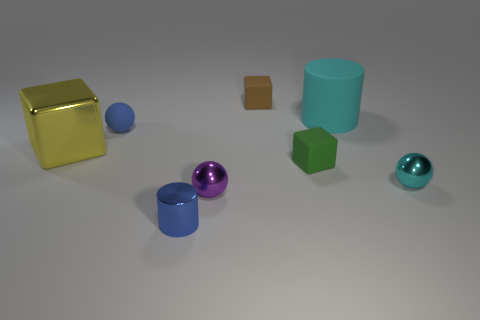How big is the block on the left side of the small ball that is to the left of the small metal cylinder?
Make the answer very short. Large. What shape is the shiny thing that is the same color as the big cylinder?
Offer a terse response. Sphere. What number of balls are gray rubber objects or cyan metallic objects?
Offer a terse response. 1. There is a green rubber cube; is its size the same as the metallic ball right of the tiny purple shiny object?
Your response must be concise. Yes. Is the number of blue metallic cylinders that are on the right side of the cyan metallic sphere greater than the number of large cyan cylinders?
Make the answer very short. No. What size is the purple object that is made of the same material as the tiny blue cylinder?
Ensure brevity in your answer.  Small. Is there a small shiny thing of the same color as the metallic cylinder?
Offer a very short reply. No. What number of objects are brown matte objects or tiny metallic things that are behind the tiny cylinder?
Give a very brief answer. 3. Is the number of small cyan metallic spheres greater than the number of matte blocks?
Your answer should be compact. No. What size is the metal thing that is the same color as the big rubber object?
Your answer should be compact. Small. 